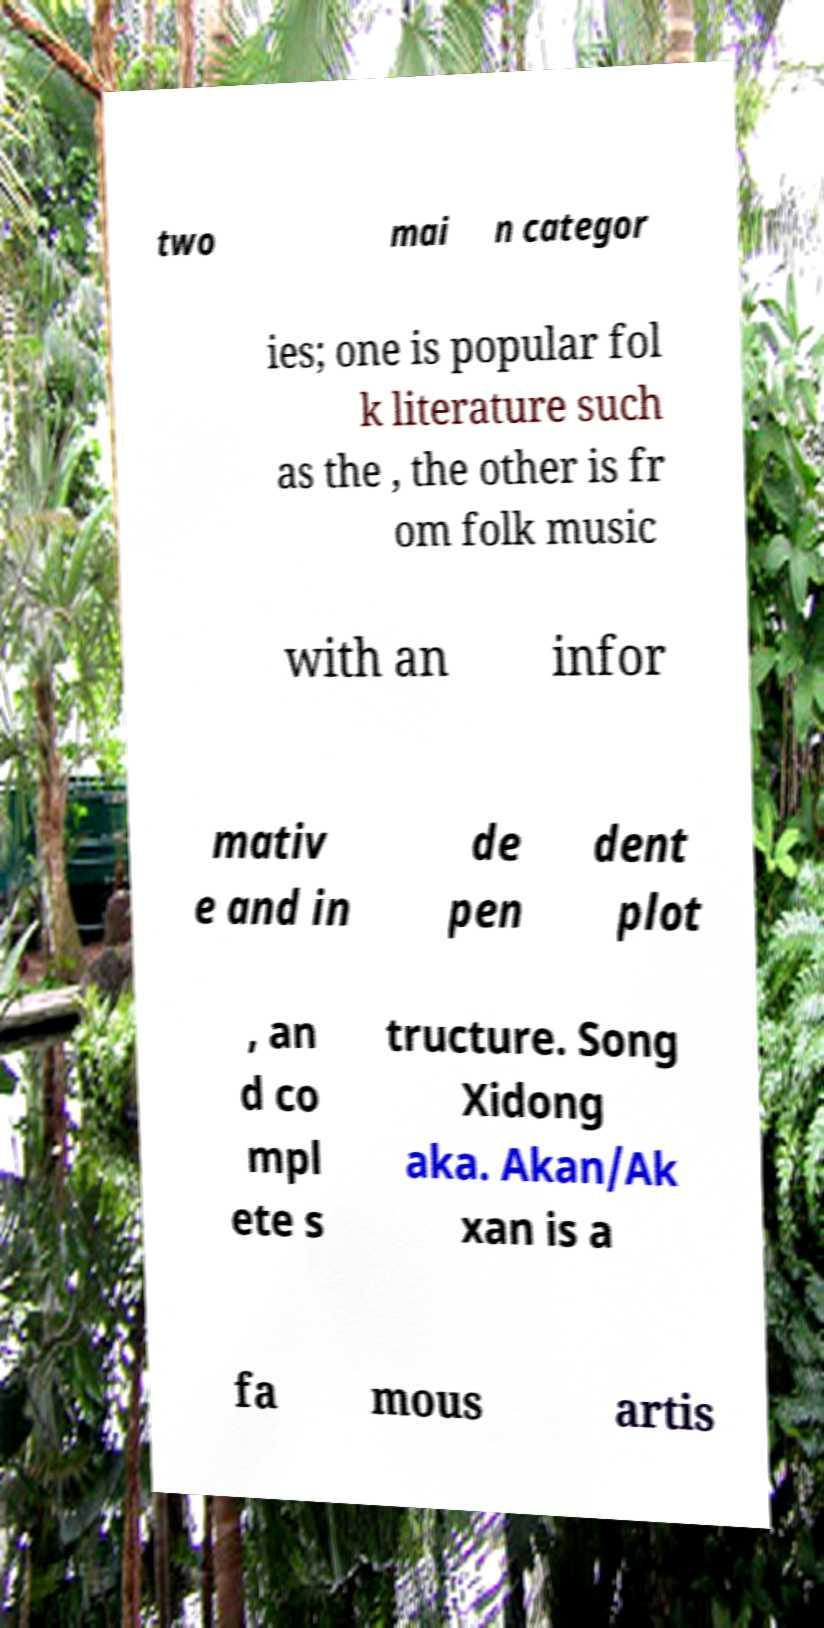Can you read and provide the text displayed in the image?This photo seems to have some interesting text. Can you extract and type it out for me? two mai n categor ies; one is popular fol k literature such as the , the other is fr om folk music with an infor mativ e and in de pen dent plot , an d co mpl ete s tructure. Song Xidong aka. Akan/Ak xan is a fa mous artis 